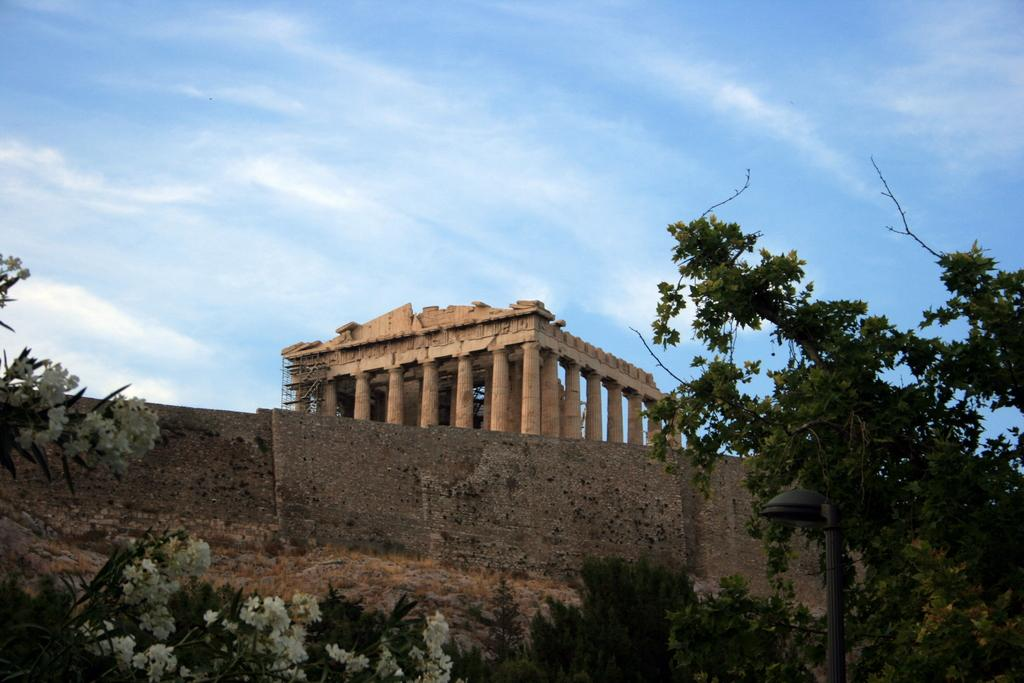What is the main structure visible in the image? There is a wall in the image. What is located in front of the wall? Trees and flowers are in front of the wall. What can be seen in the background of the image? There are pillars and the sky visible in the background of the image. Can you tell me how many children are playing on the playground in the image? There is no playground present in the image, so it is not possible to determine how many children might be playing there. 